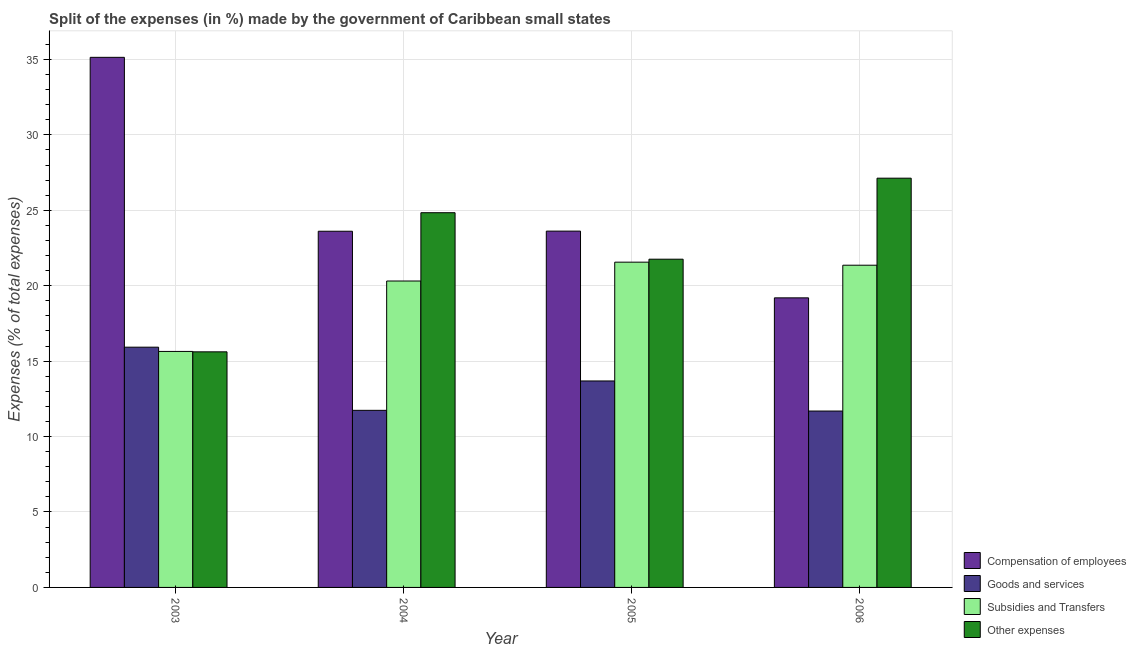How many groups of bars are there?
Give a very brief answer. 4. Are the number of bars on each tick of the X-axis equal?
Ensure brevity in your answer.  Yes. How many bars are there on the 3rd tick from the right?
Your answer should be compact. 4. In how many cases, is the number of bars for a given year not equal to the number of legend labels?
Your answer should be very brief. 0. What is the percentage of amount spent on subsidies in 2003?
Offer a very short reply. 15.64. Across all years, what is the maximum percentage of amount spent on compensation of employees?
Give a very brief answer. 35.14. Across all years, what is the minimum percentage of amount spent on compensation of employees?
Offer a terse response. 19.19. In which year was the percentage of amount spent on compensation of employees minimum?
Your answer should be compact. 2006. What is the total percentage of amount spent on subsidies in the graph?
Keep it short and to the point. 78.87. What is the difference between the percentage of amount spent on subsidies in 2003 and that in 2005?
Ensure brevity in your answer.  -5.92. What is the difference between the percentage of amount spent on goods and services in 2005 and the percentage of amount spent on other expenses in 2004?
Provide a succinct answer. 1.95. What is the average percentage of amount spent on goods and services per year?
Offer a terse response. 13.26. In how many years, is the percentage of amount spent on other expenses greater than 7 %?
Provide a short and direct response. 4. What is the ratio of the percentage of amount spent on other expenses in 2004 to that in 2005?
Offer a very short reply. 1.14. Is the percentage of amount spent on other expenses in 2004 less than that in 2006?
Provide a short and direct response. Yes. Is the difference between the percentage of amount spent on compensation of employees in 2003 and 2006 greater than the difference between the percentage of amount spent on subsidies in 2003 and 2006?
Provide a short and direct response. No. What is the difference between the highest and the second highest percentage of amount spent on compensation of employees?
Ensure brevity in your answer.  11.52. What is the difference between the highest and the lowest percentage of amount spent on compensation of employees?
Make the answer very short. 15.94. Is it the case that in every year, the sum of the percentage of amount spent on other expenses and percentage of amount spent on goods and services is greater than the sum of percentage of amount spent on compensation of employees and percentage of amount spent on subsidies?
Provide a short and direct response. No. What does the 1st bar from the left in 2004 represents?
Your answer should be very brief. Compensation of employees. What does the 1st bar from the right in 2003 represents?
Keep it short and to the point. Other expenses. Is it the case that in every year, the sum of the percentage of amount spent on compensation of employees and percentage of amount spent on goods and services is greater than the percentage of amount spent on subsidies?
Your answer should be very brief. Yes. How many bars are there?
Offer a terse response. 16. Are all the bars in the graph horizontal?
Keep it short and to the point. No. How many years are there in the graph?
Your answer should be very brief. 4. Does the graph contain any zero values?
Ensure brevity in your answer.  No. Does the graph contain grids?
Keep it short and to the point. Yes. Where does the legend appear in the graph?
Your answer should be compact. Bottom right. How many legend labels are there?
Your response must be concise. 4. How are the legend labels stacked?
Provide a succinct answer. Vertical. What is the title of the graph?
Make the answer very short. Split of the expenses (in %) made by the government of Caribbean small states. Does "First 20% of population" appear as one of the legend labels in the graph?
Provide a succinct answer. No. What is the label or title of the Y-axis?
Keep it short and to the point. Expenses (% of total expenses). What is the Expenses (% of total expenses) of Compensation of employees in 2003?
Your answer should be very brief. 35.14. What is the Expenses (% of total expenses) in Goods and services in 2003?
Your answer should be compact. 15.92. What is the Expenses (% of total expenses) of Subsidies and Transfers in 2003?
Offer a very short reply. 15.64. What is the Expenses (% of total expenses) of Other expenses in 2003?
Offer a terse response. 15.62. What is the Expenses (% of total expenses) in Compensation of employees in 2004?
Ensure brevity in your answer.  23.61. What is the Expenses (% of total expenses) in Goods and services in 2004?
Your answer should be very brief. 11.74. What is the Expenses (% of total expenses) in Subsidies and Transfers in 2004?
Offer a terse response. 20.31. What is the Expenses (% of total expenses) of Other expenses in 2004?
Keep it short and to the point. 24.84. What is the Expenses (% of total expenses) of Compensation of employees in 2005?
Keep it short and to the point. 23.62. What is the Expenses (% of total expenses) of Goods and services in 2005?
Your answer should be compact. 13.69. What is the Expenses (% of total expenses) in Subsidies and Transfers in 2005?
Offer a terse response. 21.56. What is the Expenses (% of total expenses) of Other expenses in 2005?
Provide a short and direct response. 21.76. What is the Expenses (% of total expenses) of Compensation of employees in 2006?
Offer a terse response. 19.19. What is the Expenses (% of total expenses) of Goods and services in 2006?
Your answer should be very brief. 11.69. What is the Expenses (% of total expenses) in Subsidies and Transfers in 2006?
Your answer should be very brief. 21.36. What is the Expenses (% of total expenses) in Other expenses in 2006?
Your answer should be very brief. 27.13. Across all years, what is the maximum Expenses (% of total expenses) of Compensation of employees?
Keep it short and to the point. 35.14. Across all years, what is the maximum Expenses (% of total expenses) in Goods and services?
Ensure brevity in your answer.  15.92. Across all years, what is the maximum Expenses (% of total expenses) in Subsidies and Transfers?
Provide a succinct answer. 21.56. Across all years, what is the maximum Expenses (% of total expenses) in Other expenses?
Your answer should be compact. 27.13. Across all years, what is the minimum Expenses (% of total expenses) in Compensation of employees?
Offer a terse response. 19.19. Across all years, what is the minimum Expenses (% of total expenses) in Goods and services?
Ensure brevity in your answer.  11.69. Across all years, what is the minimum Expenses (% of total expenses) of Subsidies and Transfers?
Your answer should be compact. 15.64. Across all years, what is the minimum Expenses (% of total expenses) of Other expenses?
Your answer should be compact. 15.62. What is the total Expenses (% of total expenses) in Compensation of employees in the graph?
Keep it short and to the point. 101.56. What is the total Expenses (% of total expenses) of Goods and services in the graph?
Keep it short and to the point. 53.04. What is the total Expenses (% of total expenses) of Subsidies and Transfers in the graph?
Your answer should be compact. 78.87. What is the total Expenses (% of total expenses) in Other expenses in the graph?
Offer a terse response. 89.34. What is the difference between the Expenses (% of total expenses) in Compensation of employees in 2003 and that in 2004?
Offer a terse response. 11.53. What is the difference between the Expenses (% of total expenses) of Goods and services in 2003 and that in 2004?
Your answer should be compact. 4.19. What is the difference between the Expenses (% of total expenses) of Subsidies and Transfers in 2003 and that in 2004?
Your response must be concise. -4.67. What is the difference between the Expenses (% of total expenses) in Other expenses in 2003 and that in 2004?
Keep it short and to the point. -9.22. What is the difference between the Expenses (% of total expenses) in Compensation of employees in 2003 and that in 2005?
Offer a terse response. 11.52. What is the difference between the Expenses (% of total expenses) in Goods and services in 2003 and that in 2005?
Offer a terse response. 2.24. What is the difference between the Expenses (% of total expenses) in Subsidies and Transfers in 2003 and that in 2005?
Provide a succinct answer. -5.92. What is the difference between the Expenses (% of total expenses) in Other expenses in 2003 and that in 2005?
Offer a very short reply. -6.14. What is the difference between the Expenses (% of total expenses) in Compensation of employees in 2003 and that in 2006?
Your answer should be very brief. 15.94. What is the difference between the Expenses (% of total expenses) in Goods and services in 2003 and that in 2006?
Make the answer very short. 4.23. What is the difference between the Expenses (% of total expenses) in Subsidies and Transfers in 2003 and that in 2006?
Offer a very short reply. -5.71. What is the difference between the Expenses (% of total expenses) of Other expenses in 2003 and that in 2006?
Provide a short and direct response. -11.51. What is the difference between the Expenses (% of total expenses) of Compensation of employees in 2004 and that in 2005?
Your answer should be very brief. -0.01. What is the difference between the Expenses (% of total expenses) of Goods and services in 2004 and that in 2005?
Make the answer very short. -1.95. What is the difference between the Expenses (% of total expenses) of Subsidies and Transfers in 2004 and that in 2005?
Provide a short and direct response. -1.25. What is the difference between the Expenses (% of total expenses) in Other expenses in 2004 and that in 2005?
Make the answer very short. 3.08. What is the difference between the Expenses (% of total expenses) of Compensation of employees in 2004 and that in 2006?
Make the answer very short. 4.41. What is the difference between the Expenses (% of total expenses) in Goods and services in 2004 and that in 2006?
Make the answer very short. 0.05. What is the difference between the Expenses (% of total expenses) in Subsidies and Transfers in 2004 and that in 2006?
Your answer should be compact. -1.05. What is the difference between the Expenses (% of total expenses) of Other expenses in 2004 and that in 2006?
Your response must be concise. -2.29. What is the difference between the Expenses (% of total expenses) in Compensation of employees in 2005 and that in 2006?
Give a very brief answer. 4.42. What is the difference between the Expenses (% of total expenses) in Goods and services in 2005 and that in 2006?
Provide a short and direct response. 1.99. What is the difference between the Expenses (% of total expenses) of Subsidies and Transfers in 2005 and that in 2006?
Offer a terse response. 0.2. What is the difference between the Expenses (% of total expenses) of Other expenses in 2005 and that in 2006?
Provide a short and direct response. -5.37. What is the difference between the Expenses (% of total expenses) of Compensation of employees in 2003 and the Expenses (% of total expenses) of Goods and services in 2004?
Provide a short and direct response. 23.4. What is the difference between the Expenses (% of total expenses) of Compensation of employees in 2003 and the Expenses (% of total expenses) of Subsidies and Transfers in 2004?
Your answer should be very brief. 14.83. What is the difference between the Expenses (% of total expenses) in Compensation of employees in 2003 and the Expenses (% of total expenses) in Other expenses in 2004?
Keep it short and to the point. 10.3. What is the difference between the Expenses (% of total expenses) in Goods and services in 2003 and the Expenses (% of total expenses) in Subsidies and Transfers in 2004?
Provide a succinct answer. -4.39. What is the difference between the Expenses (% of total expenses) of Goods and services in 2003 and the Expenses (% of total expenses) of Other expenses in 2004?
Ensure brevity in your answer.  -8.91. What is the difference between the Expenses (% of total expenses) of Subsidies and Transfers in 2003 and the Expenses (% of total expenses) of Other expenses in 2004?
Ensure brevity in your answer.  -9.19. What is the difference between the Expenses (% of total expenses) in Compensation of employees in 2003 and the Expenses (% of total expenses) in Goods and services in 2005?
Provide a succinct answer. 21.45. What is the difference between the Expenses (% of total expenses) in Compensation of employees in 2003 and the Expenses (% of total expenses) in Subsidies and Transfers in 2005?
Your answer should be very brief. 13.58. What is the difference between the Expenses (% of total expenses) in Compensation of employees in 2003 and the Expenses (% of total expenses) in Other expenses in 2005?
Offer a terse response. 13.38. What is the difference between the Expenses (% of total expenses) in Goods and services in 2003 and the Expenses (% of total expenses) in Subsidies and Transfers in 2005?
Provide a short and direct response. -5.64. What is the difference between the Expenses (% of total expenses) in Goods and services in 2003 and the Expenses (% of total expenses) in Other expenses in 2005?
Provide a succinct answer. -5.83. What is the difference between the Expenses (% of total expenses) in Subsidies and Transfers in 2003 and the Expenses (% of total expenses) in Other expenses in 2005?
Offer a terse response. -6.11. What is the difference between the Expenses (% of total expenses) of Compensation of employees in 2003 and the Expenses (% of total expenses) of Goods and services in 2006?
Your answer should be compact. 23.45. What is the difference between the Expenses (% of total expenses) of Compensation of employees in 2003 and the Expenses (% of total expenses) of Subsidies and Transfers in 2006?
Keep it short and to the point. 13.78. What is the difference between the Expenses (% of total expenses) of Compensation of employees in 2003 and the Expenses (% of total expenses) of Other expenses in 2006?
Offer a very short reply. 8.01. What is the difference between the Expenses (% of total expenses) in Goods and services in 2003 and the Expenses (% of total expenses) in Subsidies and Transfers in 2006?
Make the answer very short. -5.43. What is the difference between the Expenses (% of total expenses) of Goods and services in 2003 and the Expenses (% of total expenses) of Other expenses in 2006?
Make the answer very short. -11.2. What is the difference between the Expenses (% of total expenses) in Subsidies and Transfers in 2003 and the Expenses (% of total expenses) in Other expenses in 2006?
Offer a terse response. -11.48. What is the difference between the Expenses (% of total expenses) in Compensation of employees in 2004 and the Expenses (% of total expenses) in Goods and services in 2005?
Offer a very short reply. 9.92. What is the difference between the Expenses (% of total expenses) in Compensation of employees in 2004 and the Expenses (% of total expenses) in Subsidies and Transfers in 2005?
Your response must be concise. 2.05. What is the difference between the Expenses (% of total expenses) in Compensation of employees in 2004 and the Expenses (% of total expenses) in Other expenses in 2005?
Your response must be concise. 1.85. What is the difference between the Expenses (% of total expenses) in Goods and services in 2004 and the Expenses (% of total expenses) in Subsidies and Transfers in 2005?
Keep it short and to the point. -9.82. What is the difference between the Expenses (% of total expenses) in Goods and services in 2004 and the Expenses (% of total expenses) in Other expenses in 2005?
Make the answer very short. -10.02. What is the difference between the Expenses (% of total expenses) in Subsidies and Transfers in 2004 and the Expenses (% of total expenses) in Other expenses in 2005?
Offer a very short reply. -1.45. What is the difference between the Expenses (% of total expenses) in Compensation of employees in 2004 and the Expenses (% of total expenses) in Goods and services in 2006?
Your answer should be compact. 11.92. What is the difference between the Expenses (% of total expenses) in Compensation of employees in 2004 and the Expenses (% of total expenses) in Subsidies and Transfers in 2006?
Offer a terse response. 2.25. What is the difference between the Expenses (% of total expenses) in Compensation of employees in 2004 and the Expenses (% of total expenses) in Other expenses in 2006?
Give a very brief answer. -3.52. What is the difference between the Expenses (% of total expenses) of Goods and services in 2004 and the Expenses (% of total expenses) of Subsidies and Transfers in 2006?
Offer a very short reply. -9.62. What is the difference between the Expenses (% of total expenses) of Goods and services in 2004 and the Expenses (% of total expenses) of Other expenses in 2006?
Your answer should be very brief. -15.39. What is the difference between the Expenses (% of total expenses) of Subsidies and Transfers in 2004 and the Expenses (% of total expenses) of Other expenses in 2006?
Offer a terse response. -6.82. What is the difference between the Expenses (% of total expenses) in Compensation of employees in 2005 and the Expenses (% of total expenses) in Goods and services in 2006?
Offer a very short reply. 11.93. What is the difference between the Expenses (% of total expenses) of Compensation of employees in 2005 and the Expenses (% of total expenses) of Subsidies and Transfers in 2006?
Offer a very short reply. 2.26. What is the difference between the Expenses (% of total expenses) of Compensation of employees in 2005 and the Expenses (% of total expenses) of Other expenses in 2006?
Provide a short and direct response. -3.51. What is the difference between the Expenses (% of total expenses) of Goods and services in 2005 and the Expenses (% of total expenses) of Subsidies and Transfers in 2006?
Provide a succinct answer. -7.67. What is the difference between the Expenses (% of total expenses) in Goods and services in 2005 and the Expenses (% of total expenses) in Other expenses in 2006?
Provide a short and direct response. -13.44. What is the difference between the Expenses (% of total expenses) of Subsidies and Transfers in 2005 and the Expenses (% of total expenses) of Other expenses in 2006?
Make the answer very short. -5.57. What is the average Expenses (% of total expenses) of Compensation of employees per year?
Your answer should be compact. 25.39. What is the average Expenses (% of total expenses) of Goods and services per year?
Give a very brief answer. 13.26. What is the average Expenses (% of total expenses) of Subsidies and Transfers per year?
Your answer should be compact. 19.72. What is the average Expenses (% of total expenses) of Other expenses per year?
Provide a short and direct response. 22.33. In the year 2003, what is the difference between the Expenses (% of total expenses) in Compensation of employees and Expenses (% of total expenses) in Goods and services?
Your answer should be compact. 19.21. In the year 2003, what is the difference between the Expenses (% of total expenses) in Compensation of employees and Expenses (% of total expenses) in Subsidies and Transfers?
Provide a succinct answer. 19.49. In the year 2003, what is the difference between the Expenses (% of total expenses) in Compensation of employees and Expenses (% of total expenses) in Other expenses?
Ensure brevity in your answer.  19.52. In the year 2003, what is the difference between the Expenses (% of total expenses) in Goods and services and Expenses (% of total expenses) in Subsidies and Transfers?
Your answer should be compact. 0.28. In the year 2003, what is the difference between the Expenses (% of total expenses) in Goods and services and Expenses (% of total expenses) in Other expenses?
Keep it short and to the point. 0.31. In the year 2003, what is the difference between the Expenses (% of total expenses) of Subsidies and Transfers and Expenses (% of total expenses) of Other expenses?
Offer a terse response. 0.03. In the year 2004, what is the difference between the Expenses (% of total expenses) of Compensation of employees and Expenses (% of total expenses) of Goods and services?
Give a very brief answer. 11.87. In the year 2004, what is the difference between the Expenses (% of total expenses) of Compensation of employees and Expenses (% of total expenses) of Subsidies and Transfers?
Offer a very short reply. 3.3. In the year 2004, what is the difference between the Expenses (% of total expenses) in Compensation of employees and Expenses (% of total expenses) in Other expenses?
Provide a succinct answer. -1.23. In the year 2004, what is the difference between the Expenses (% of total expenses) of Goods and services and Expenses (% of total expenses) of Subsidies and Transfers?
Offer a terse response. -8.57. In the year 2004, what is the difference between the Expenses (% of total expenses) of Goods and services and Expenses (% of total expenses) of Other expenses?
Make the answer very short. -13.1. In the year 2004, what is the difference between the Expenses (% of total expenses) in Subsidies and Transfers and Expenses (% of total expenses) in Other expenses?
Your response must be concise. -4.53. In the year 2005, what is the difference between the Expenses (% of total expenses) of Compensation of employees and Expenses (% of total expenses) of Goods and services?
Provide a short and direct response. 9.93. In the year 2005, what is the difference between the Expenses (% of total expenses) of Compensation of employees and Expenses (% of total expenses) of Subsidies and Transfers?
Your response must be concise. 2.06. In the year 2005, what is the difference between the Expenses (% of total expenses) in Compensation of employees and Expenses (% of total expenses) in Other expenses?
Give a very brief answer. 1.86. In the year 2005, what is the difference between the Expenses (% of total expenses) of Goods and services and Expenses (% of total expenses) of Subsidies and Transfers?
Your answer should be compact. -7.87. In the year 2005, what is the difference between the Expenses (% of total expenses) in Goods and services and Expenses (% of total expenses) in Other expenses?
Provide a short and direct response. -8.07. In the year 2005, what is the difference between the Expenses (% of total expenses) of Subsidies and Transfers and Expenses (% of total expenses) of Other expenses?
Offer a terse response. -0.2. In the year 2006, what is the difference between the Expenses (% of total expenses) of Compensation of employees and Expenses (% of total expenses) of Goods and services?
Your answer should be compact. 7.5. In the year 2006, what is the difference between the Expenses (% of total expenses) in Compensation of employees and Expenses (% of total expenses) in Subsidies and Transfers?
Your answer should be compact. -2.16. In the year 2006, what is the difference between the Expenses (% of total expenses) in Compensation of employees and Expenses (% of total expenses) in Other expenses?
Your answer should be very brief. -7.93. In the year 2006, what is the difference between the Expenses (% of total expenses) in Goods and services and Expenses (% of total expenses) in Subsidies and Transfers?
Your response must be concise. -9.67. In the year 2006, what is the difference between the Expenses (% of total expenses) in Goods and services and Expenses (% of total expenses) in Other expenses?
Make the answer very short. -15.43. In the year 2006, what is the difference between the Expenses (% of total expenses) in Subsidies and Transfers and Expenses (% of total expenses) in Other expenses?
Provide a short and direct response. -5.77. What is the ratio of the Expenses (% of total expenses) in Compensation of employees in 2003 to that in 2004?
Keep it short and to the point. 1.49. What is the ratio of the Expenses (% of total expenses) in Goods and services in 2003 to that in 2004?
Keep it short and to the point. 1.36. What is the ratio of the Expenses (% of total expenses) in Subsidies and Transfers in 2003 to that in 2004?
Your answer should be very brief. 0.77. What is the ratio of the Expenses (% of total expenses) of Other expenses in 2003 to that in 2004?
Provide a short and direct response. 0.63. What is the ratio of the Expenses (% of total expenses) in Compensation of employees in 2003 to that in 2005?
Make the answer very short. 1.49. What is the ratio of the Expenses (% of total expenses) in Goods and services in 2003 to that in 2005?
Offer a very short reply. 1.16. What is the ratio of the Expenses (% of total expenses) in Subsidies and Transfers in 2003 to that in 2005?
Give a very brief answer. 0.73. What is the ratio of the Expenses (% of total expenses) of Other expenses in 2003 to that in 2005?
Your answer should be very brief. 0.72. What is the ratio of the Expenses (% of total expenses) in Compensation of employees in 2003 to that in 2006?
Your answer should be very brief. 1.83. What is the ratio of the Expenses (% of total expenses) of Goods and services in 2003 to that in 2006?
Give a very brief answer. 1.36. What is the ratio of the Expenses (% of total expenses) in Subsidies and Transfers in 2003 to that in 2006?
Your answer should be very brief. 0.73. What is the ratio of the Expenses (% of total expenses) of Other expenses in 2003 to that in 2006?
Give a very brief answer. 0.58. What is the ratio of the Expenses (% of total expenses) of Compensation of employees in 2004 to that in 2005?
Ensure brevity in your answer.  1. What is the ratio of the Expenses (% of total expenses) in Goods and services in 2004 to that in 2005?
Offer a terse response. 0.86. What is the ratio of the Expenses (% of total expenses) of Subsidies and Transfers in 2004 to that in 2005?
Your answer should be very brief. 0.94. What is the ratio of the Expenses (% of total expenses) in Other expenses in 2004 to that in 2005?
Ensure brevity in your answer.  1.14. What is the ratio of the Expenses (% of total expenses) of Compensation of employees in 2004 to that in 2006?
Provide a succinct answer. 1.23. What is the ratio of the Expenses (% of total expenses) in Subsidies and Transfers in 2004 to that in 2006?
Your answer should be very brief. 0.95. What is the ratio of the Expenses (% of total expenses) of Other expenses in 2004 to that in 2006?
Your answer should be compact. 0.92. What is the ratio of the Expenses (% of total expenses) in Compensation of employees in 2005 to that in 2006?
Ensure brevity in your answer.  1.23. What is the ratio of the Expenses (% of total expenses) in Goods and services in 2005 to that in 2006?
Offer a terse response. 1.17. What is the ratio of the Expenses (% of total expenses) in Subsidies and Transfers in 2005 to that in 2006?
Keep it short and to the point. 1.01. What is the ratio of the Expenses (% of total expenses) in Other expenses in 2005 to that in 2006?
Your response must be concise. 0.8. What is the difference between the highest and the second highest Expenses (% of total expenses) in Compensation of employees?
Your answer should be very brief. 11.52. What is the difference between the highest and the second highest Expenses (% of total expenses) in Goods and services?
Ensure brevity in your answer.  2.24. What is the difference between the highest and the second highest Expenses (% of total expenses) in Subsidies and Transfers?
Give a very brief answer. 0.2. What is the difference between the highest and the second highest Expenses (% of total expenses) in Other expenses?
Provide a short and direct response. 2.29. What is the difference between the highest and the lowest Expenses (% of total expenses) in Compensation of employees?
Give a very brief answer. 15.94. What is the difference between the highest and the lowest Expenses (% of total expenses) in Goods and services?
Your answer should be very brief. 4.23. What is the difference between the highest and the lowest Expenses (% of total expenses) of Subsidies and Transfers?
Keep it short and to the point. 5.92. What is the difference between the highest and the lowest Expenses (% of total expenses) of Other expenses?
Make the answer very short. 11.51. 